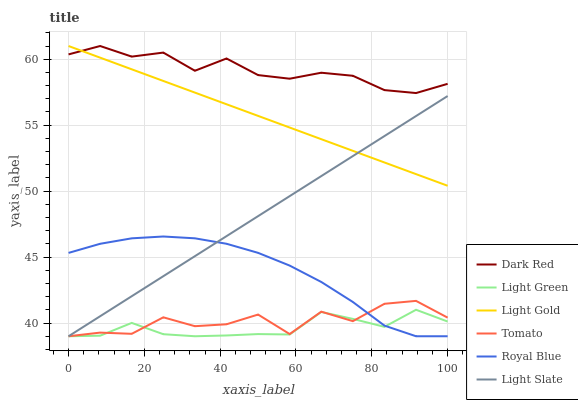Does Light Green have the minimum area under the curve?
Answer yes or no. Yes. Does Dark Red have the maximum area under the curve?
Answer yes or no. Yes. Does Light Slate have the minimum area under the curve?
Answer yes or no. No. Does Light Slate have the maximum area under the curve?
Answer yes or no. No. Is Light Slate the smoothest?
Answer yes or no. Yes. Is Tomato the roughest?
Answer yes or no. Yes. Is Dark Red the smoothest?
Answer yes or no. No. Is Dark Red the roughest?
Answer yes or no. No. Does Tomato have the lowest value?
Answer yes or no. Yes. Does Dark Red have the lowest value?
Answer yes or no. No. Does Light Gold have the highest value?
Answer yes or no. Yes. Does Light Slate have the highest value?
Answer yes or no. No. Is Tomato less than Dark Red?
Answer yes or no. Yes. Is Dark Red greater than Light Slate?
Answer yes or no. Yes. Does Light Green intersect Light Slate?
Answer yes or no. Yes. Is Light Green less than Light Slate?
Answer yes or no. No. Is Light Green greater than Light Slate?
Answer yes or no. No. Does Tomato intersect Dark Red?
Answer yes or no. No. 